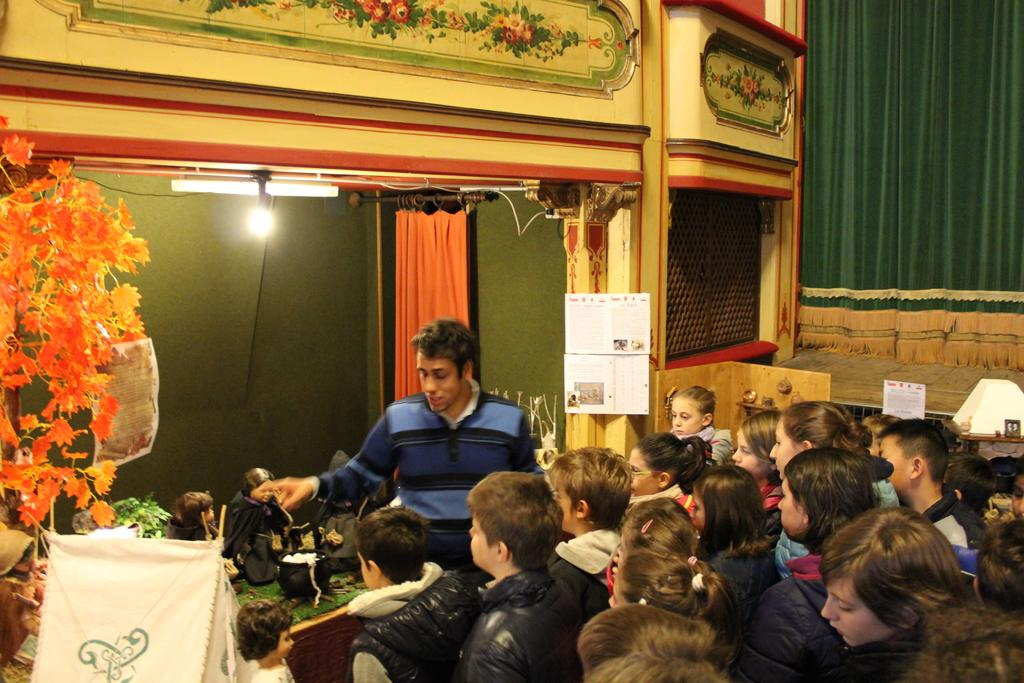How many people are in the image? There is a group of people in the image, but the exact number is not specified. Can you describe the man in the group? A man is standing among the group. What type of window treatment is present in the image? There are curtains in the image. What can be used to provide illumination in the image? There are lights in the image. What type of decorative elements are present in the image? There are flowers and posters in the image. What other objects can be seen in the image? There are other objects present in the image, but their specific nature is not mentioned. What type of yarn is being used to create the base of the sculpture in the image? There is no sculpture or yarn present in the image. 